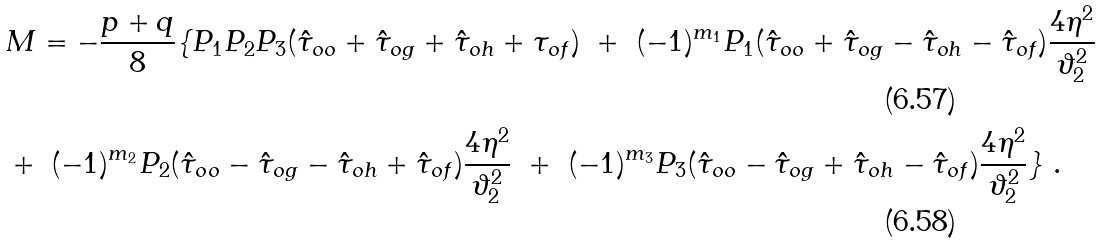Convert formula to latex. <formula><loc_0><loc_0><loc_500><loc_500>& M = - \frac { p + q } { 8 } \{ P _ { 1 } P _ { 2 } P _ { 3 } ( { \hat { \tau } _ { o o } } + { \hat { \tau } _ { o g } } + { \hat { \tau } _ { o h } } + \tau _ { o f } ) \ + \ ( - 1 ) ^ { m _ { 1 } } P _ { 1 } ( { \hat { \tau } _ { o o } } + { \hat { \tau } _ { o g } } - { \hat { \tau } _ { o h } } - { \hat { \tau } _ { o f } } ) \frac { 4 \eta ^ { 2 } } { \vartheta _ { 2 } ^ { 2 } } \\ & + \ ( - 1 ) ^ { m _ { 2 } } P _ { 2 } ( { \hat { \tau } _ { o o } } - { \hat { \tau } _ { o g } } - { \hat { \tau } _ { o h } } + { \hat { \tau } _ { o f } } ) \frac { 4 \eta ^ { 2 } } { \vartheta _ { 2 } ^ { 2 } } \ + \ ( - 1 ) ^ { m _ { 3 } } P _ { 3 } ( { \hat { \tau } _ { o o } } - { \hat { \tau } _ { o g } } + { \hat { \tau } _ { o h } } - { \hat { \tau } _ { o f } } ) \frac { 4 \eta ^ { 2 } } { \vartheta _ { 2 } ^ { 2 } } \} \ .</formula> 